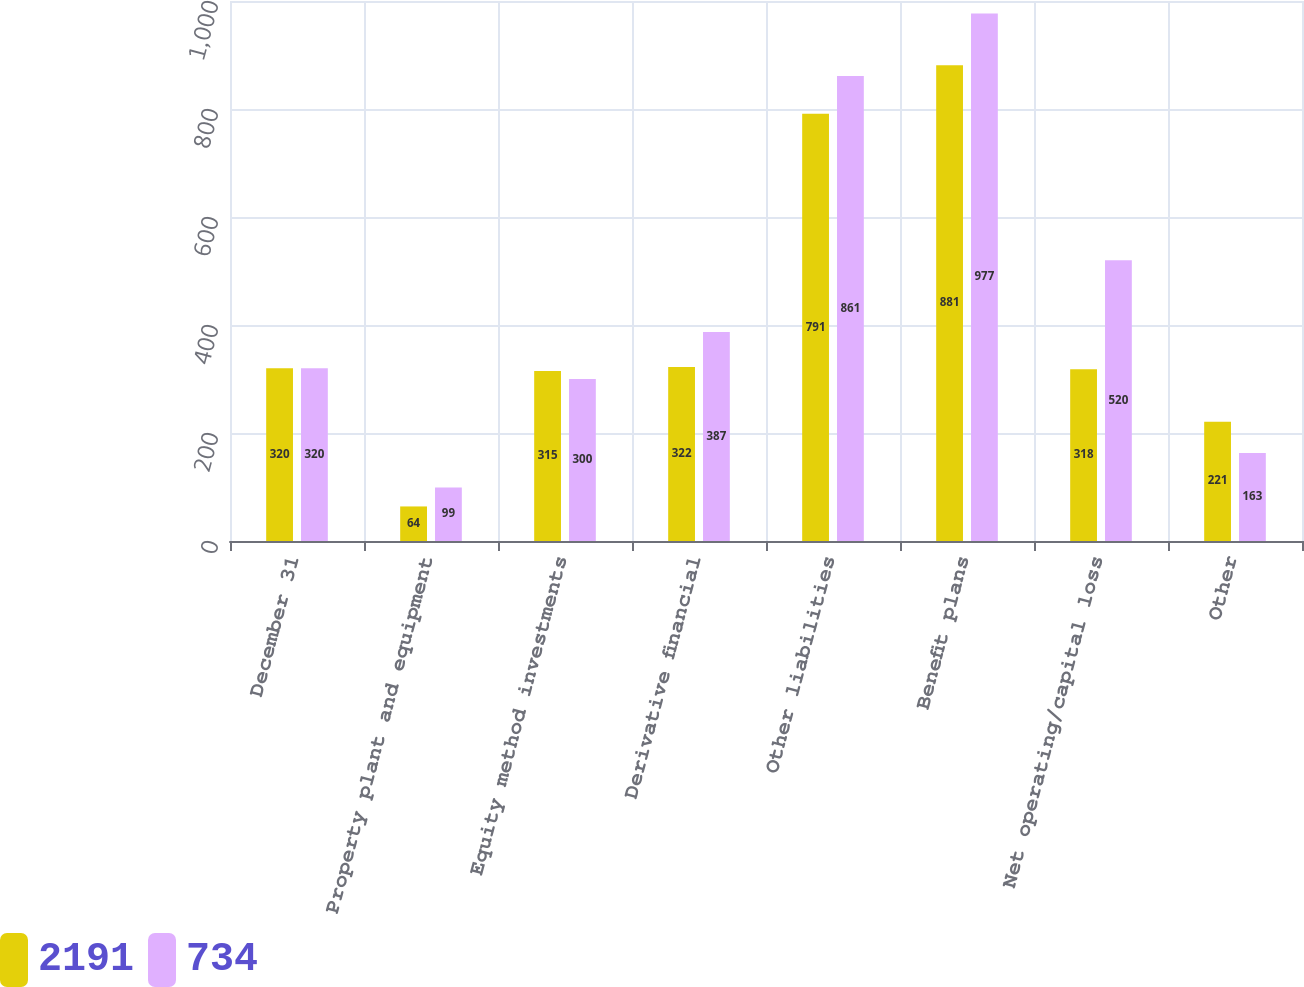Convert chart. <chart><loc_0><loc_0><loc_500><loc_500><stacked_bar_chart><ecel><fcel>December 31<fcel>Property plant and equipment<fcel>Equity method investments<fcel>Derivative financial<fcel>Other liabilities<fcel>Benefit plans<fcel>Net operating/capital loss<fcel>Other<nl><fcel>2191<fcel>320<fcel>64<fcel>315<fcel>322<fcel>791<fcel>881<fcel>318<fcel>221<nl><fcel>734<fcel>320<fcel>99<fcel>300<fcel>387<fcel>861<fcel>977<fcel>520<fcel>163<nl></chart> 